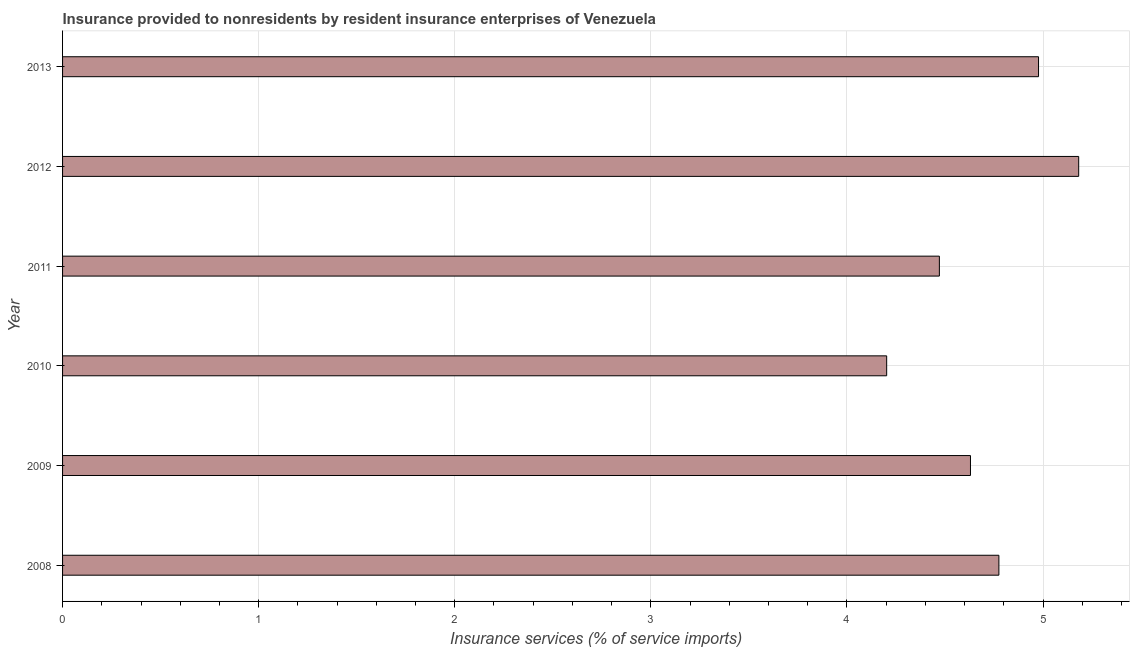What is the title of the graph?
Ensure brevity in your answer.  Insurance provided to nonresidents by resident insurance enterprises of Venezuela. What is the label or title of the X-axis?
Provide a succinct answer. Insurance services (% of service imports). What is the label or title of the Y-axis?
Keep it short and to the point. Year. What is the insurance and financial services in 2008?
Your answer should be compact. 4.77. Across all years, what is the maximum insurance and financial services?
Provide a succinct answer. 5.18. Across all years, what is the minimum insurance and financial services?
Provide a short and direct response. 4.2. In which year was the insurance and financial services maximum?
Offer a terse response. 2012. What is the sum of the insurance and financial services?
Provide a short and direct response. 28.24. What is the difference between the insurance and financial services in 2010 and 2011?
Provide a succinct answer. -0.27. What is the average insurance and financial services per year?
Your answer should be very brief. 4.71. What is the median insurance and financial services?
Give a very brief answer. 4.7. What is the ratio of the insurance and financial services in 2009 to that in 2012?
Your answer should be compact. 0.89. Is the insurance and financial services in 2012 less than that in 2013?
Your answer should be very brief. No. Is the difference between the insurance and financial services in 2009 and 2011 greater than the difference between any two years?
Your response must be concise. No. What is the difference between the highest and the second highest insurance and financial services?
Provide a succinct answer. 0.2. How many bars are there?
Give a very brief answer. 6. How many years are there in the graph?
Provide a short and direct response. 6. What is the difference between two consecutive major ticks on the X-axis?
Keep it short and to the point. 1. What is the Insurance services (% of service imports) of 2008?
Offer a very short reply. 4.77. What is the Insurance services (% of service imports) in 2009?
Your response must be concise. 4.63. What is the Insurance services (% of service imports) in 2010?
Your response must be concise. 4.2. What is the Insurance services (% of service imports) in 2011?
Offer a very short reply. 4.47. What is the Insurance services (% of service imports) in 2012?
Provide a short and direct response. 5.18. What is the Insurance services (% of service imports) in 2013?
Give a very brief answer. 4.98. What is the difference between the Insurance services (% of service imports) in 2008 and 2009?
Ensure brevity in your answer.  0.14. What is the difference between the Insurance services (% of service imports) in 2008 and 2010?
Your answer should be very brief. 0.57. What is the difference between the Insurance services (% of service imports) in 2008 and 2011?
Your answer should be compact. 0.3. What is the difference between the Insurance services (% of service imports) in 2008 and 2012?
Offer a very short reply. -0.41. What is the difference between the Insurance services (% of service imports) in 2008 and 2013?
Provide a short and direct response. -0.2. What is the difference between the Insurance services (% of service imports) in 2009 and 2010?
Ensure brevity in your answer.  0.43. What is the difference between the Insurance services (% of service imports) in 2009 and 2011?
Offer a very short reply. 0.16. What is the difference between the Insurance services (% of service imports) in 2009 and 2012?
Provide a succinct answer. -0.55. What is the difference between the Insurance services (% of service imports) in 2009 and 2013?
Keep it short and to the point. -0.35. What is the difference between the Insurance services (% of service imports) in 2010 and 2011?
Keep it short and to the point. -0.27. What is the difference between the Insurance services (% of service imports) in 2010 and 2012?
Give a very brief answer. -0.98. What is the difference between the Insurance services (% of service imports) in 2010 and 2013?
Ensure brevity in your answer.  -0.77. What is the difference between the Insurance services (% of service imports) in 2011 and 2012?
Your answer should be very brief. -0.71. What is the difference between the Insurance services (% of service imports) in 2011 and 2013?
Offer a very short reply. -0.51. What is the difference between the Insurance services (% of service imports) in 2012 and 2013?
Provide a succinct answer. 0.2. What is the ratio of the Insurance services (% of service imports) in 2008 to that in 2009?
Provide a short and direct response. 1.03. What is the ratio of the Insurance services (% of service imports) in 2008 to that in 2010?
Offer a very short reply. 1.14. What is the ratio of the Insurance services (% of service imports) in 2008 to that in 2011?
Your answer should be very brief. 1.07. What is the ratio of the Insurance services (% of service imports) in 2008 to that in 2012?
Keep it short and to the point. 0.92. What is the ratio of the Insurance services (% of service imports) in 2009 to that in 2010?
Ensure brevity in your answer.  1.1. What is the ratio of the Insurance services (% of service imports) in 2009 to that in 2011?
Provide a succinct answer. 1.03. What is the ratio of the Insurance services (% of service imports) in 2009 to that in 2012?
Give a very brief answer. 0.89. What is the ratio of the Insurance services (% of service imports) in 2009 to that in 2013?
Provide a succinct answer. 0.93. What is the ratio of the Insurance services (% of service imports) in 2010 to that in 2012?
Ensure brevity in your answer.  0.81. What is the ratio of the Insurance services (% of service imports) in 2010 to that in 2013?
Your response must be concise. 0.84. What is the ratio of the Insurance services (% of service imports) in 2011 to that in 2012?
Keep it short and to the point. 0.86. What is the ratio of the Insurance services (% of service imports) in 2011 to that in 2013?
Your response must be concise. 0.9. What is the ratio of the Insurance services (% of service imports) in 2012 to that in 2013?
Provide a succinct answer. 1.04. 